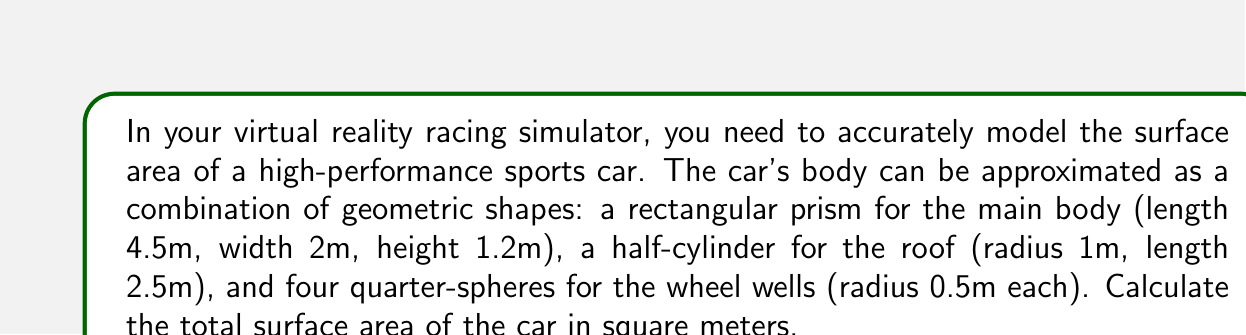Solve this math problem. Let's break this down step-by-step:

1. Rectangular prism (main body):
   Surface area = $2(lw + lh + wh)$
   $$ SA_{body} = 2(4.5 \times 2 + 4.5 \times 1.2 + 2 \times 1.2) = 39.6 \text{ m}^2 $$

2. Half-cylinder (roof):
   Surface area = $\pi r l + \pi r^2$
   $$ SA_{roof} = \pi \times 1 \times 2.5 + \pi \times 1^2 = 10.996 \text{ m}^2 $$

3. Quarter-spheres (wheel wells):
   Surface area of one quarter-sphere = $\frac{1}{4} \times 4\pi r^2 = \pi r^2$
   For four wheel wells: $4 \times \pi r^2$
   $$ SA_{wheels} = 4 \times \pi \times 0.5^2 = \pi \text{ m}^2 $$

4. Total surface area:
   $$ SA_{total} = SA_{body} + SA_{roof} + SA_{wheels} $$
   $$ SA_{total} = 39.6 + 10.996 + \pi $$
   $$ SA_{total} = 50.596 + \pi \text{ m}^2 $$
   $$ SA_{total} \approx 53.732 \text{ m}^2 $$
Answer: $53.732 \text{ m}^2$ 